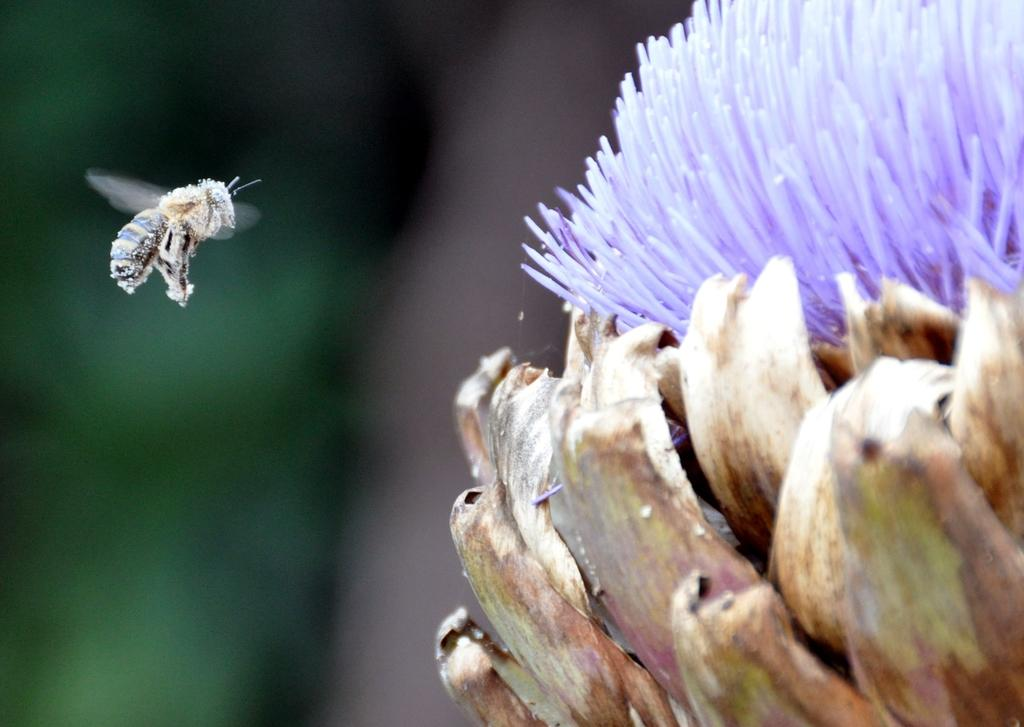What is the main subject of the image? There is a flower in the image. What else can be seen in the image besides the flower? An insect is flying in the air in the image. Can you describe the background of the image? The background of the image is blurred. What type of trousers is the insect wearing in the image? Insects do not wear trousers, and there is no mention of trousers in the image. 